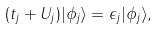Convert formula to latex. <formula><loc_0><loc_0><loc_500><loc_500>( t _ { j } + U _ { j } ) | \phi _ { j } \rangle = \epsilon _ { j } | \phi _ { j } \rangle ,</formula> 